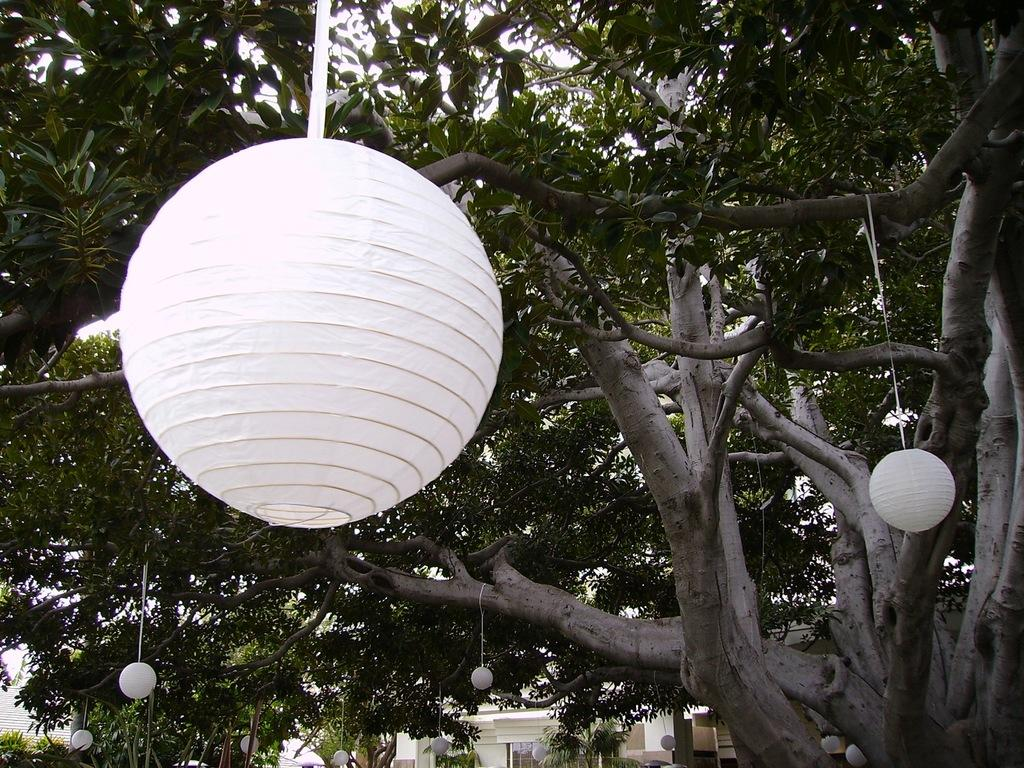What is hanging from the branches of the tree in the image? There are decorative lamps hanging from the branches of a tree in the image. What can be seen in the background of the image? There is a building in the background of the image. Can you see a donkey standing near the tree in the image? No, there is no donkey present in the image. What type of sense can be experienced from the decorative lamps in the image? The decorative lamps in the image are visual objects, so they primarily engage the sense of sight. However, they may also provide a sense of ambiance or atmosphere, which could be considered a more abstract sense. 